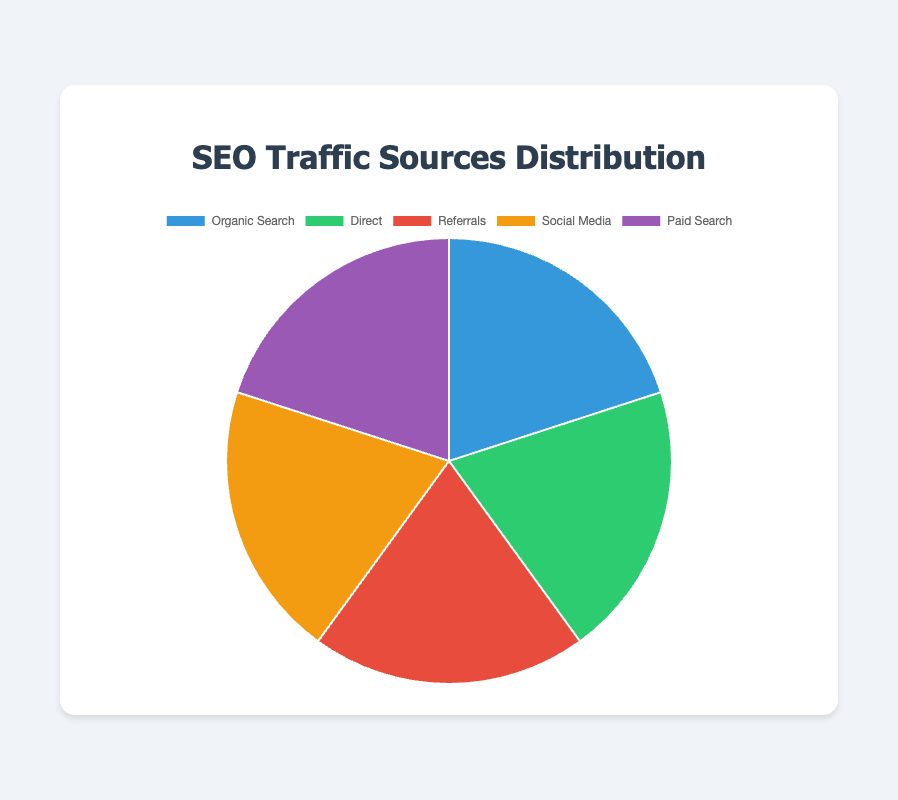What is the total percentage of all traffic sources combined? To find the total percentage of all traffic sources combined, we add the percentages of the individual traffic sources. The percentages are Google (65.2), Bing (15.8), Yahoo (10.3), DuckDuckGo (4.7), Baidu (4.0), Direct (100.0), Reddit (30.1), Stack Overflow (25.6), GitHub (18.3), Quora (15.0), Medium (11.0), Twitter (35.4), LinkedIn (30.2), Facebook (20.3), Instagram (10.1), Pinterest (4.0), Google Ads (72.0), Bing Ads (15.0), Facebook Ads (8.0), LinkedIn Ads (5.0). The total is 465.0%.
Answer: 465% Which traffic source contributes the most to overall SEO traffic? The pie chart shows the distribution of traffic sources by the area covered with distinct colors. The largest section represents "Direct" with 100% of the traffic coming from it.
Answer: Direct Which two sources of organic search traffic contribute a total of more than 25%? From the pie chart, the contributions of traffic sources in Organic Search are: Google (65.2%), Bing (15.8%), Yahoo (10.3%), DuckDuckGo (4.7%), Baidu (4.0%). Summing up the contributions: Bing (<15.8%>) + Yahoo (<10.3%>) = <26.1%>. So the two sources contributing more than 25% together are Bing and Yahoo.
Answer: Bing and Yahoo How does the contribution of Reddit referrals compare to GitHub referrals? From the pie chart, the contributions of Reddit and GitHub as referral traffic sources are represented. Reddit contributes 30.1% while GitHub contributes 18.3%, so, Reddit contributes more referral traffic than GitHub.
Answer: Reddit contributes more Which social media source has the smallest contribution, and what’s its percentage? The social media traffic sources on the pie chart list their percentages: Twitter (35.4%), LinkedIn (30.2%), Facebook (20.3%), Instagram (10.1%), Pinterest (4.0%). The smallest contribution is from Pinterest with 4.0%.
Answer: Pinterest, 4.0% Combine the contributions of paid search traffic sources. What is their total? To find the total contribution from paid search traffic sources, sum the percentages of Google Ads (72.0%), Bing Ads (15.0%), Facebook Ads (8.0%), LinkedIn Ads (5.0). Total is 72.0% + 15.0% + 8.0% + 5.0% = 100%.
Answer: 100% What is the difference in the contribution between Google and Bing in organic search? To find the difference in contribution between Google and Bing in organic search, subtract Bing’s percentage (15.8%) from Google’s percentage (65.2%). 65.2% - 15.8% = 49.4%.
Answer: 49.4% Which traffic source in ‘Referrals’ provides nearer to the average percentage among listed entities? Average percentage for referral sources = (30.1% + 25.6% + 18.3% + 15.0% + 11.0%) / 5 = 20%. Stack Overflow has 25.6% which is close to but higher than the average 20%, and GitHub has 18.3%, which is the nearest to the average.
Answer: GitHub 